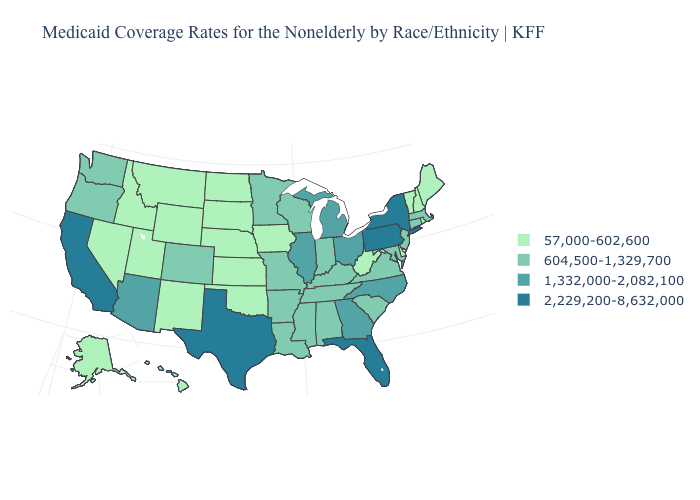Does the first symbol in the legend represent the smallest category?
Answer briefly. Yes. What is the value of Washington?
Short answer required. 604,500-1,329,700. Name the states that have a value in the range 2,229,200-8,632,000?
Short answer required. California, Florida, New York, Pennsylvania, Texas. Does Missouri have a lower value than Delaware?
Write a very short answer. No. Does Kentucky have the lowest value in the USA?
Short answer required. No. Which states hav the highest value in the MidWest?
Short answer required. Illinois, Michigan, Ohio. Does Alaska have a lower value than Montana?
Concise answer only. No. What is the highest value in the USA?
Answer briefly. 2,229,200-8,632,000. Name the states that have a value in the range 1,332,000-2,082,100?
Answer briefly. Arizona, Georgia, Illinois, Michigan, North Carolina, Ohio. Does New Mexico have a lower value than Pennsylvania?
Give a very brief answer. Yes. What is the highest value in the Northeast ?
Answer briefly. 2,229,200-8,632,000. Does Missouri have the highest value in the MidWest?
Be succinct. No. Among the states that border New Hampshire , which have the highest value?
Write a very short answer. Massachusetts. What is the lowest value in the USA?
Answer briefly. 57,000-602,600. What is the value of Wisconsin?
Quick response, please. 604,500-1,329,700. 